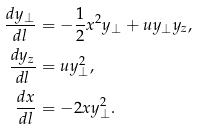Convert formula to latex. <formula><loc_0><loc_0><loc_500><loc_500>\frac { d y _ { \perp } } { d l } & = - \frac { 1 } { 2 } x ^ { 2 } y _ { \perp } + u y _ { \perp } y _ { z } , \\ \frac { d y _ { z } } { d l } & = u y _ { \perp } ^ { 2 } , \\ \frac { d x } { d l } & = - 2 x y _ { \perp } ^ { 2 } .</formula> 